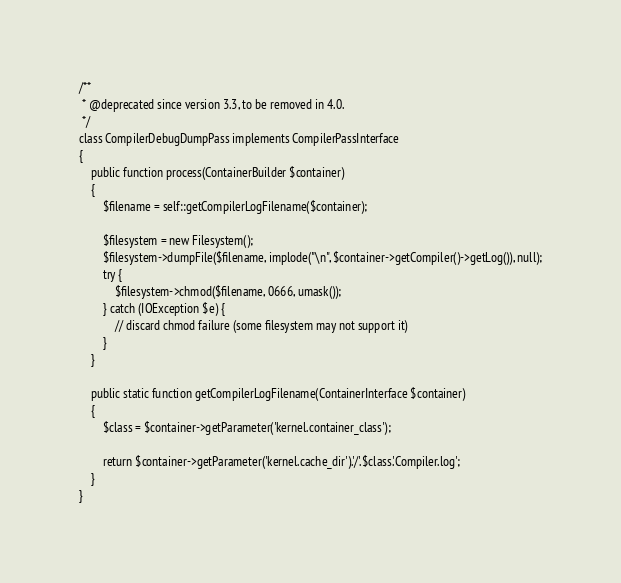<code> <loc_0><loc_0><loc_500><loc_500><_PHP_>/**
 * @deprecated since version 3.3, to be removed in 4.0.
 */
class CompilerDebugDumpPass implements CompilerPassInterface
{
    public function process(ContainerBuilder $container)
    {
        $filename = self::getCompilerLogFilename($container);

        $filesystem = new Filesystem();
        $filesystem->dumpFile($filename, implode("\n", $container->getCompiler()->getLog()), null);
        try {
            $filesystem->chmod($filename, 0666, umask());
        } catch (IOException $e) {
            // discard chmod failure (some filesystem may not support it)
        }
    }

    public static function getCompilerLogFilename(ContainerInterface $container)
    {
        $class = $container->getParameter('kernel.container_class');

        return $container->getParameter('kernel.cache_dir').'/'.$class.'Compiler.log';
    }
}
</code> 